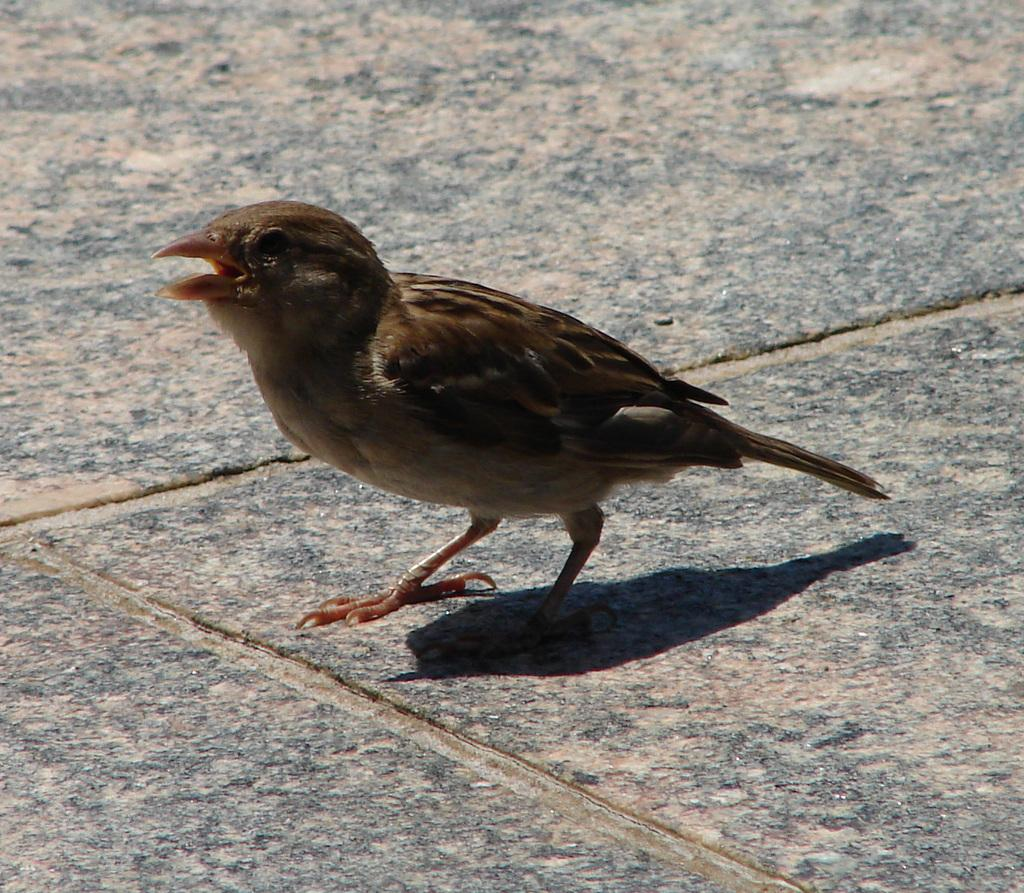What type of animal is present in the image? There is a bird in the image. Can you describe the surface on which the bird is standing? The bird is on a marble surface. What type of stocking is the government wearing in the image? There is no reference to stockings or a government in the image; it features a bird on a marble surface. 